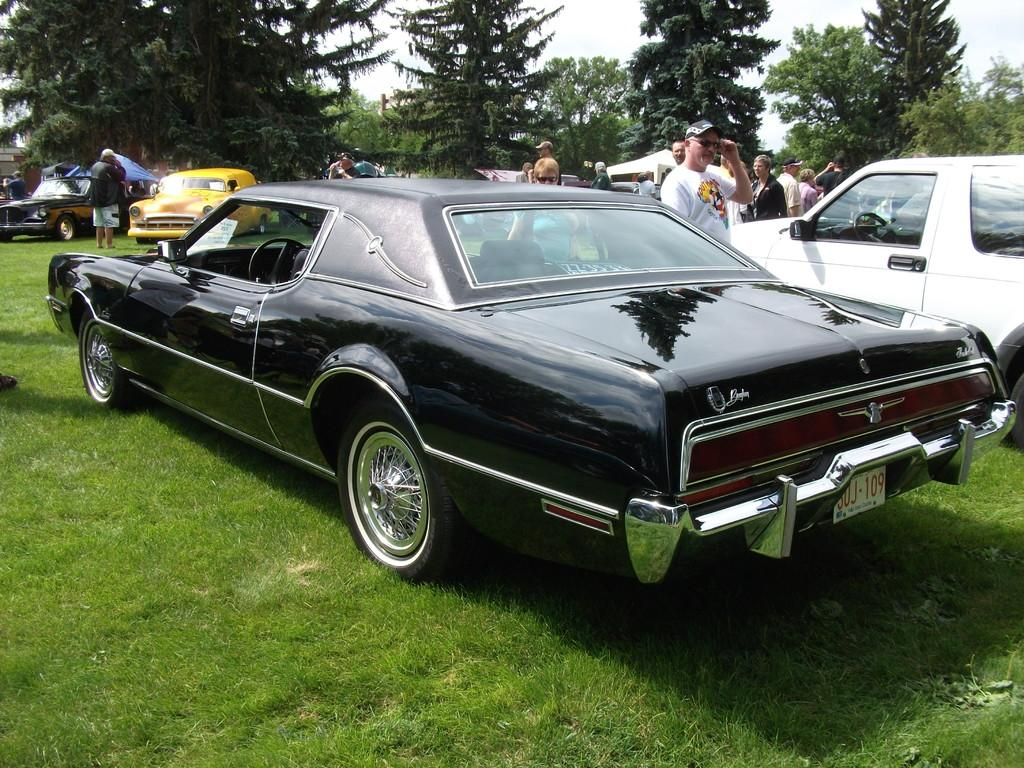What type of vehicles can be seen in the image? There are cars in the image. Who or what else is present in the image besides the cars? There are people in the image. Where are the people located in the image? The people are on the grass. What type of natural elements can be seen in the image? There are trees visible in the image. What is the title of the book the writer is holding in the image? There is no writer or book present in the image. What type of material is the brick wall made of in the image? There is no brick wall present in the image. 